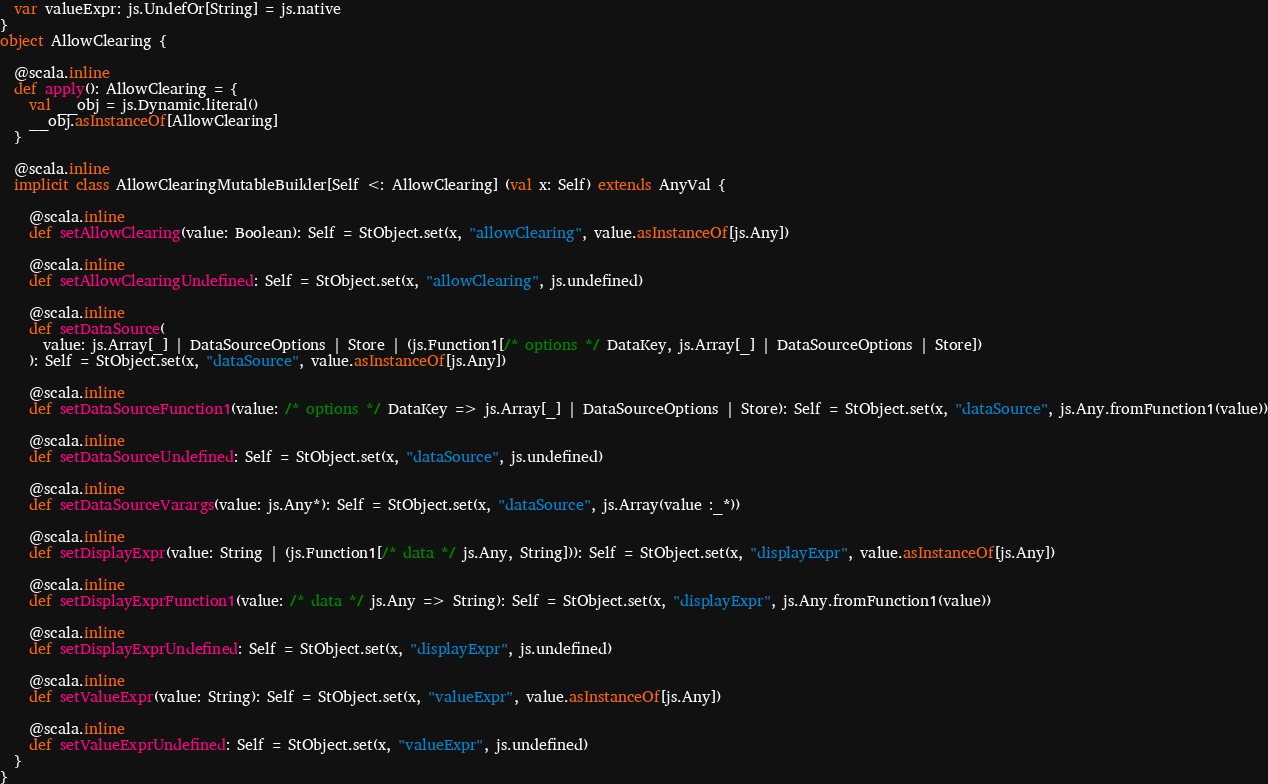Convert code to text. <code><loc_0><loc_0><loc_500><loc_500><_Scala_>  var valueExpr: js.UndefOr[String] = js.native
}
object AllowClearing {
  
  @scala.inline
  def apply(): AllowClearing = {
    val __obj = js.Dynamic.literal()
    __obj.asInstanceOf[AllowClearing]
  }
  
  @scala.inline
  implicit class AllowClearingMutableBuilder[Self <: AllowClearing] (val x: Self) extends AnyVal {
    
    @scala.inline
    def setAllowClearing(value: Boolean): Self = StObject.set(x, "allowClearing", value.asInstanceOf[js.Any])
    
    @scala.inline
    def setAllowClearingUndefined: Self = StObject.set(x, "allowClearing", js.undefined)
    
    @scala.inline
    def setDataSource(
      value: js.Array[_] | DataSourceOptions | Store | (js.Function1[/* options */ DataKey, js.Array[_] | DataSourceOptions | Store])
    ): Self = StObject.set(x, "dataSource", value.asInstanceOf[js.Any])
    
    @scala.inline
    def setDataSourceFunction1(value: /* options */ DataKey => js.Array[_] | DataSourceOptions | Store): Self = StObject.set(x, "dataSource", js.Any.fromFunction1(value))
    
    @scala.inline
    def setDataSourceUndefined: Self = StObject.set(x, "dataSource", js.undefined)
    
    @scala.inline
    def setDataSourceVarargs(value: js.Any*): Self = StObject.set(x, "dataSource", js.Array(value :_*))
    
    @scala.inline
    def setDisplayExpr(value: String | (js.Function1[/* data */ js.Any, String])): Self = StObject.set(x, "displayExpr", value.asInstanceOf[js.Any])
    
    @scala.inline
    def setDisplayExprFunction1(value: /* data */ js.Any => String): Self = StObject.set(x, "displayExpr", js.Any.fromFunction1(value))
    
    @scala.inline
    def setDisplayExprUndefined: Self = StObject.set(x, "displayExpr", js.undefined)
    
    @scala.inline
    def setValueExpr(value: String): Self = StObject.set(x, "valueExpr", value.asInstanceOf[js.Any])
    
    @scala.inline
    def setValueExprUndefined: Self = StObject.set(x, "valueExpr", js.undefined)
  }
}
</code> 